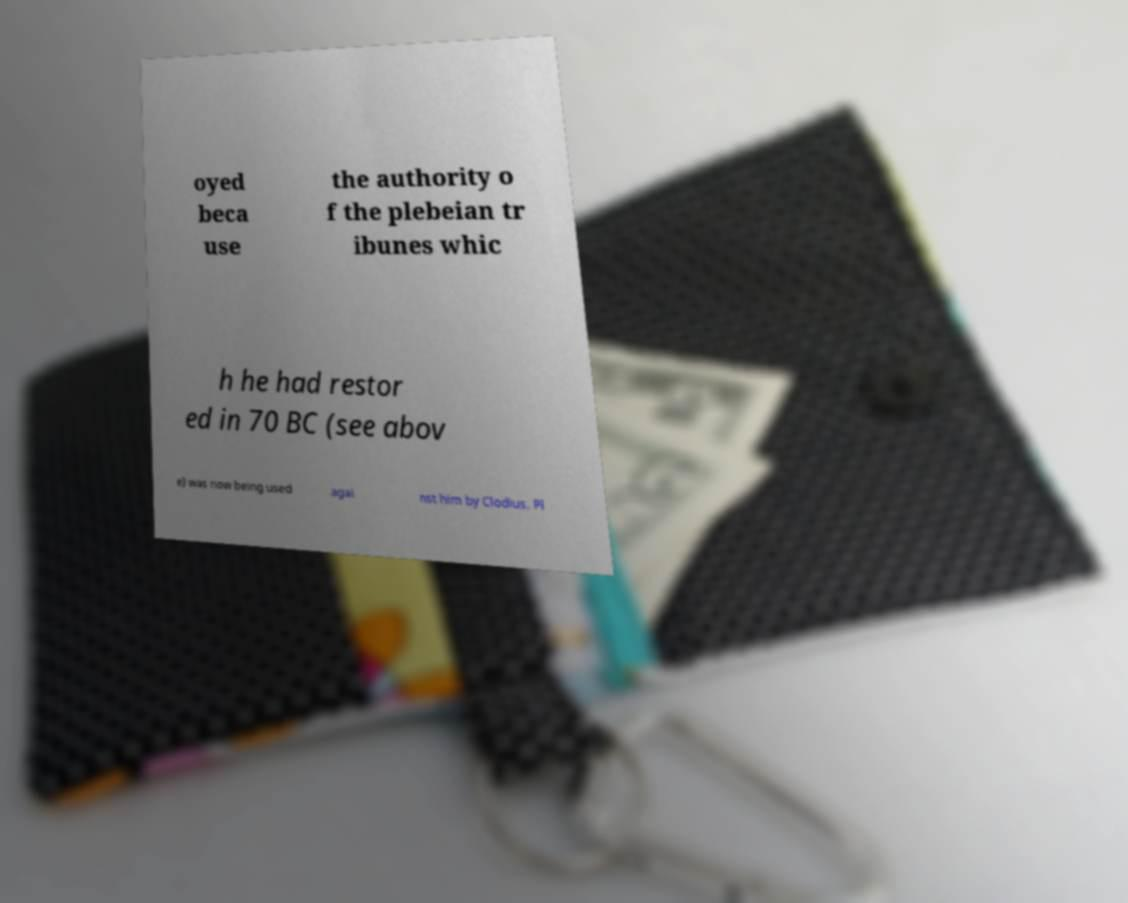Can you read and provide the text displayed in the image?This photo seems to have some interesting text. Can you extract and type it out for me? oyed beca use the authority o f the plebeian tr ibunes whic h he had restor ed in 70 BC (see abov e) was now being used agai nst him by Clodius. Pl 